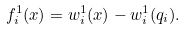<formula> <loc_0><loc_0><loc_500><loc_500>f _ { i } ^ { 1 } ( x ) = w _ { i } ^ { 1 } ( x ) - w _ { i } ^ { 1 } ( q _ { i } ) .</formula> 